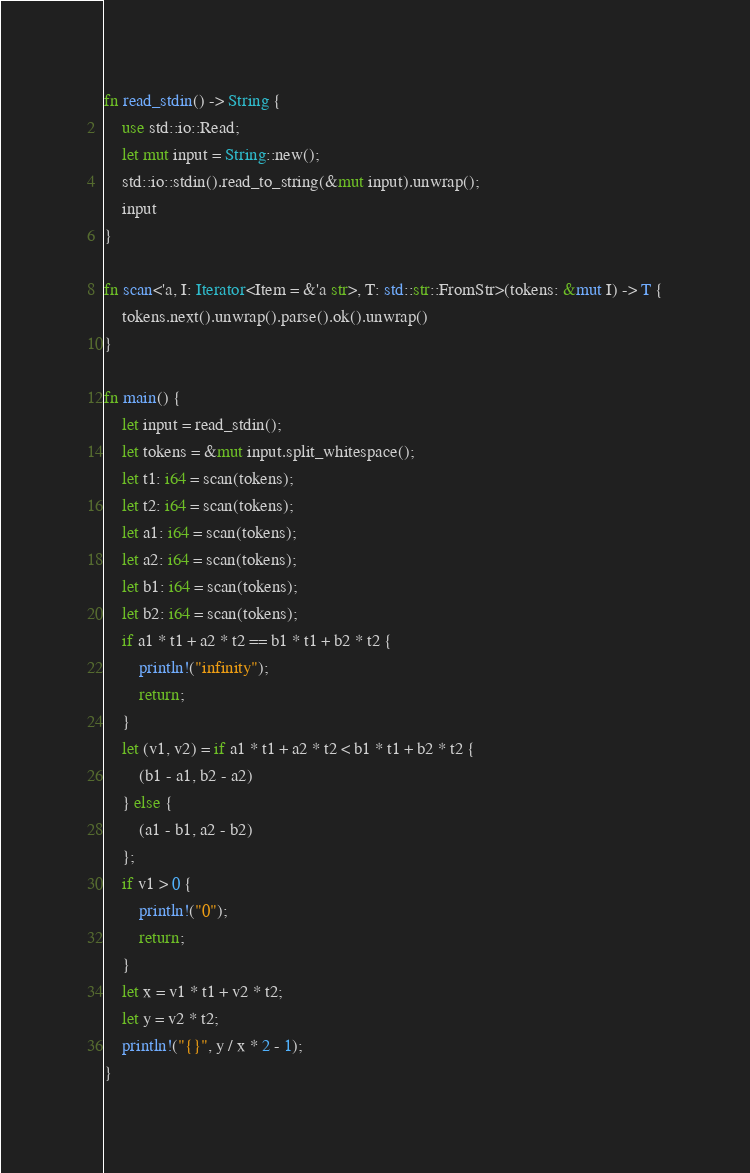Convert code to text. <code><loc_0><loc_0><loc_500><loc_500><_Rust_>fn read_stdin() -> String {
    use std::io::Read;
    let mut input = String::new();
    std::io::stdin().read_to_string(&mut input).unwrap();
    input
}

fn scan<'a, I: Iterator<Item = &'a str>, T: std::str::FromStr>(tokens: &mut I) -> T {
    tokens.next().unwrap().parse().ok().unwrap()
}

fn main() {
    let input = read_stdin();
    let tokens = &mut input.split_whitespace();
    let t1: i64 = scan(tokens);
    let t2: i64 = scan(tokens);
    let a1: i64 = scan(tokens);
    let a2: i64 = scan(tokens);
    let b1: i64 = scan(tokens);
    let b2: i64 = scan(tokens);
    if a1 * t1 + a2 * t2 == b1 * t1 + b2 * t2 {
        println!("infinity");
        return;
    }
    let (v1, v2) = if a1 * t1 + a2 * t2 < b1 * t1 + b2 * t2 {
        (b1 - a1, b2 - a2)
    } else {
        (a1 - b1, a2 - b2)
    };
    if v1 > 0 {
        println!("0");
        return;
    }
    let x = v1 * t1 + v2 * t2;
    let y = v2 * t2;
    println!("{}", y / x * 2 - 1);
}
</code> 